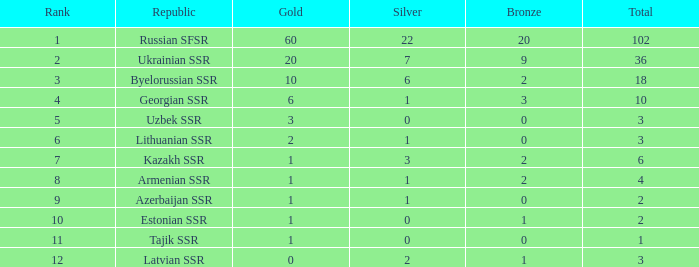What is the sum of silvers for teams with ranks over 3 and totals under 2? 0.0. 